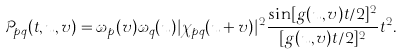Convert formula to latex. <formula><loc_0><loc_0><loc_500><loc_500>\mathcal { P } _ { p q } ( t , u , v ) = \omega _ { p } ( v ) \omega _ { q } ( u ) | \chi _ { p q } ( u + v ) | ^ { 2 } \frac { \sin [ g ( u , v ) t / 2 ] ^ { 2 } } { [ g ( u , v ) t / 2 ] ^ { 2 } } t ^ { 2 } .</formula> 